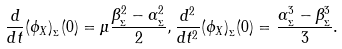Convert formula to latex. <formula><loc_0><loc_0><loc_500><loc_500>\frac { d } { d t } ( \phi _ { X } ) _ { _ { \Sigma } } ( 0 ) = \mu \frac { \beta _ { _ { \Sigma } } ^ { 2 } - \alpha _ { _ { \Sigma } } ^ { 2 } } { 2 } , \frac { d ^ { 2 } } { d t ^ { 2 } } ( \phi _ { X } ) _ { _ { \Sigma } } ( 0 ) = \frac { \alpha _ { _ { \Sigma } } ^ { 3 } - \beta _ { _ { \Sigma } } ^ { 3 } } { 3 } .</formula> 